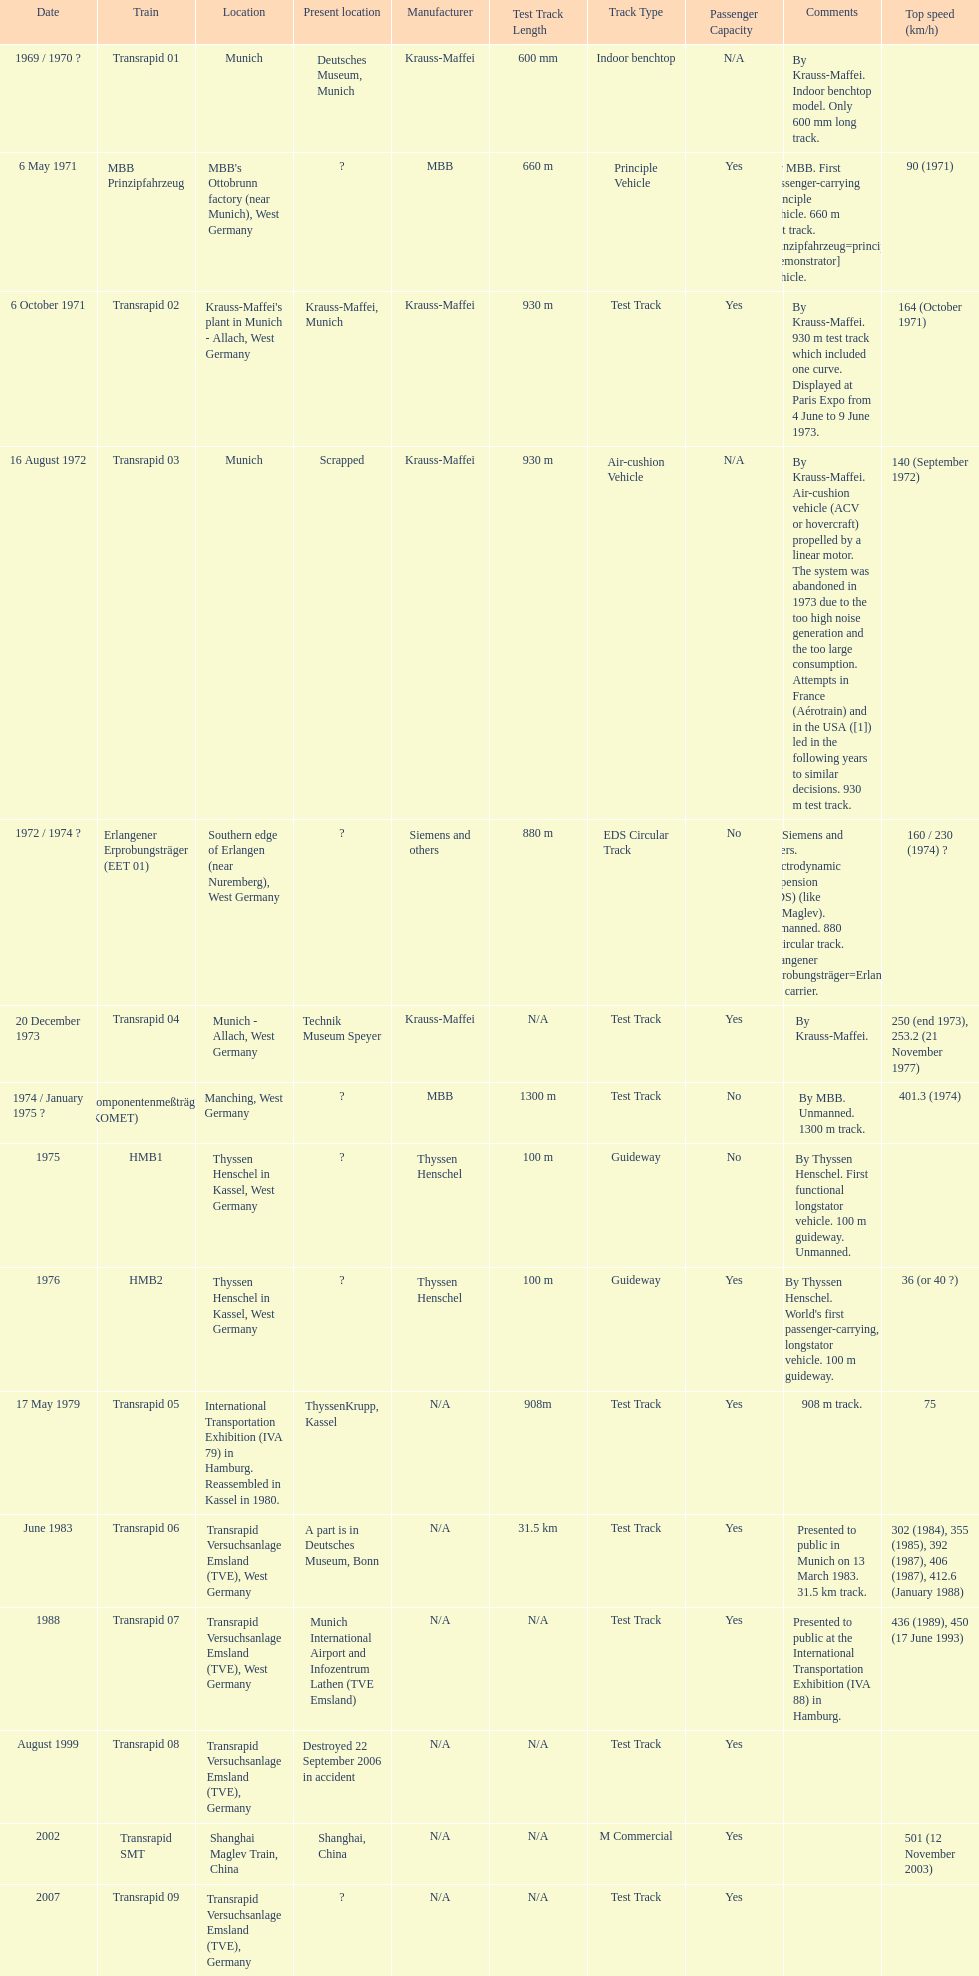Which train has the least top speed? HMB2. Can you give me this table as a dict? {'header': ['Date', 'Train', 'Location', 'Present location', 'Manufacturer', 'Test Track Length', 'Track Type', 'Passenger Capacity', 'Comments', 'Top speed (km/h)'], 'rows': [['1969 / 1970\xa0?', 'Transrapid 01', 'Munich', 'Deutsches Museum, Munich', 'Krauss-Maffei', '600 mm', 'Indoor benchtop', 'N/A', 'By Krauss-Maffei. Indoor benchtop model. Only 600\xa0mm long track.', ''], ['6 May 1971', 'MBB Prinzipfahrzeug', "MBB's Ottobrunn factory (near Munich), West Germany", '?', 'MBB', '660 m', 'Principle Vehicle', 'Yes', 'By MBB. First passenger-carrying principle vehicle. 660 m test track. Prinzipfahrzeug=principle [demonstrator] vehicle.', '90 (1971)'], ['6 October 1971', 'Transrapid 02', "Krauss-Maffei's plant in Munich - Allach, West Germany", 'Krauss-Maffei, Munich', 'Krauss-Maffei', '930 m', 'Test Track', 'Yes', 'By Krauss-Maffei. 930 m test track which included one curve. Displayed at Paris Expo from 4 June to 9 June 1973.', '164 (October 1971)'], ['16 August 1972', 'Transrapid 03', 'Munich', 'Scrapped', 'Krauss-Maffei', '930 m', 'Air-cushion Vehicle', 'N/A', 'By Krauss-Maffei. Air-cushion vehicle (ACV or hovercraft) propelled by a linear motor. The system was abandoned in 1973 due to the too high noise generation and the too large consumption. Attempts in France (Aérotrain) and in the USA ([1]) led in the following years to similar decisions. 930 m test track.', '140 (September 1972)'], ['1972 / 1974\xa0?', 'Erlangener Erprobungsträger (EET 01)', 'Southern edge of Erlangen (near Nuremberg), West Germany', '?', 'Siemens and others', '880 m', 'EDS Circular Track', 'No', 'By Siemens and others. Electrodynamic suspension (EDS) (like JR-Maglev). Unmanned. 880 m circular track. Erlangener Erprobungsträger=Erlangen test carrier.', '160 / 230 (1974)\xa0?'], ['20 December 1973', 'Transrapid 04', 'Munich - Allach, West Germany', 'Technik Museum Speyer', 'Krauss-Maffei', 'N/A', 'Test Track', 'Yes', 'By Krauss-Maffei.', '250 (end 1973), 253.2 (21 November 1977)'], ['1974 / January 1975\xa0?', 'Komponentenmeßträger (KOMET)', 'Manching, West Germany', '?', 'MBB', '1300 m', 'Test Track', 'No', 'By MBB. Unmanned. 1300 m track.', '401.3 (1974)'], ['1975', 'HMB1', 'Thyssen Henschel in Kassel, West Germany', '?', 'Thyssen Henschel', '100 m', 'Guideway', 'No', 'By Thyssen Henschel. First functional longstator vehicle. 100 m guideway. Unmanned.', ''], ['1976', 'HMB2', 'Thyssen Henschel in Kassel, West Germany', '?', 'Thyssen Henschel', '100 m', 'Guideway', 'Yes', "By Thyssen Henschel. World's first passenger-carrying, longstator vehicle. 100 m guideway.", '36 (or 40\xa0?)'], ['17 May 1979', 'Transrapid 05', 'International Transportation Exhibition (IVA 79) in Hamburg. Reassembled in Kassel in 1980.', 'ThyssenKrupp, Kassel', 'N/A', '908m', 'Test Track', 'Yes', '908 m track.', '75'], ['June 1983', 'Transrapid 06', 'Transrapid Versuchsanlage Emsland (TVE), West Germany', 'A part is in Deutsches Museum, Bonn', 'N/A', '31.5 km', 'Test Track', 'Yes', 'Presented to public in Munich on 13 March 1983. 31.5\xa0km track.', '302 (1984), 355 (1985), 392 (1987), 406 (1987), 412.6 (January 1988)'], ['1988', 'Transrapid 07', 'Transrapid Versuchsanlage Emsland (TVE), West Germany', 'Munich International Airport and Infozentrum Lathen (TVE Emsland)', 'N/A', 'N/A', 'Test Track', 'Yes', 'Presented to public at the International Transportation Exhibition (IVA 88) in Hamburg.', '436 (1989), 450 (17 June 1993)'], ['August 1999', 'Transrapid 08', 'Transrapid Versuchsanlage Emsland (TVE), Germany', 'Destroyed 22 September 2006 in accident', 'N/A', 'N/A', 'Test Track', 'Yes', '', ''], ['2002', 'Transrapid SMT', 'Shanghai Maglev Train, China', 'Shanghai, China', 'N/A', 'N/A', 'M Commercial', 'Yes', '', '501 (12 November 2003)'], ['2007', 'Transrapid 09', 'Transrapid Versuchsanlage Emsland (TVE), Germany', '?', 'N/A', 'N/A', 'Test Track', 'Yes', '', '']]} 